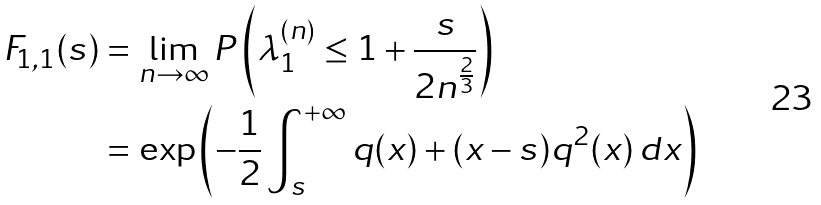<formula> <loc_0><loc_0><loc_500><loc_500>F _ { 1 , 1 } ( s ) & = \lim _ { n \rightarrow \infty } P \left ( \lambda ^ { ( n ) } _ { 1 } \leq 1 + \frac { s } { 2 n ^ { \frac { 2 } { 3 } } } \right ) \\ & = \exp \left ( - \frac { 1 } { 2 } \int ^ { + \infty } _ { s } q ( x ) + ( x - s ) q ^ { 2 } ( x ) \, d x \right )</formula> 